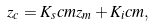Convert formula to latex. <formula><loc_0><loc_0><loc_500><loc_500>z _ { c } = K _ { s } c m z _ { m } + K _ { i } c m ,</formula> 